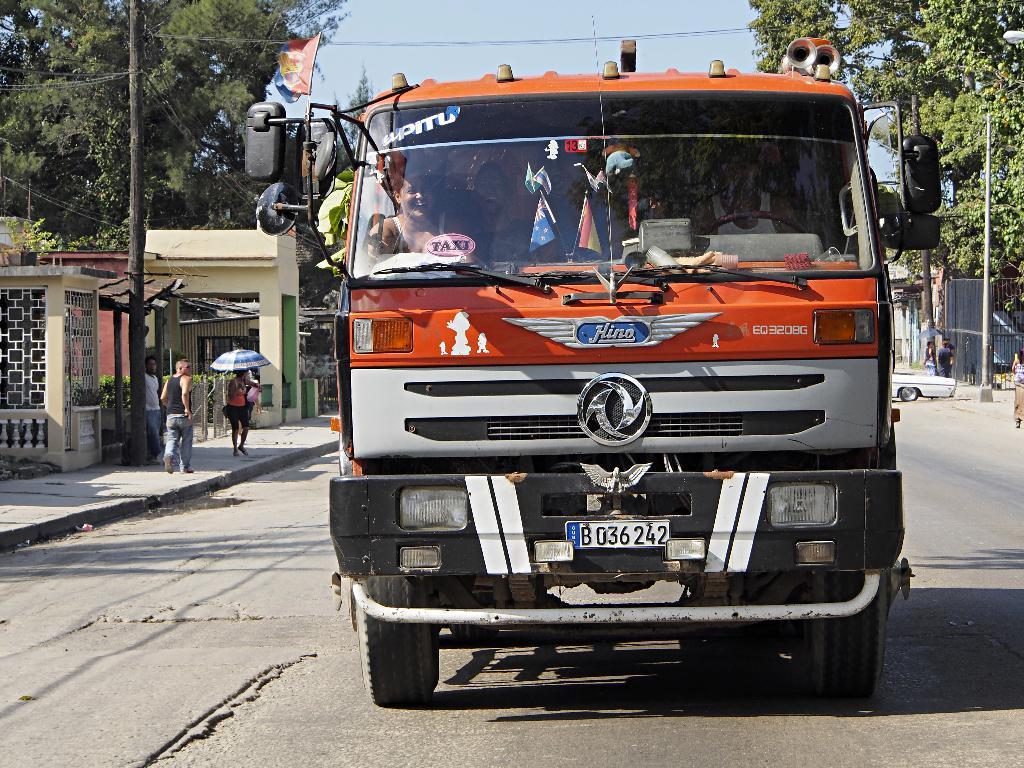Please provide a concise description of this image. In the background we can see the sky. On either of the road we can see trees and people. In this picture we can see a vehicle on the road. Through the glass we can see objects and people. On the left side of the picture we can see houses. At the bottom we can see the shadow of a vehicle. 